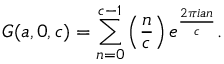Convert formula to latex. <formula><loc_0><loc_0><loc_500><loc_500>G ( a , 0 , c ) = \sum _ { n = 0 } ^ { c - 1 } \left ( { \frac { n } { c } } \right ) e ^ { \frac { 2 \pi i a n } { c } } .</formula> 